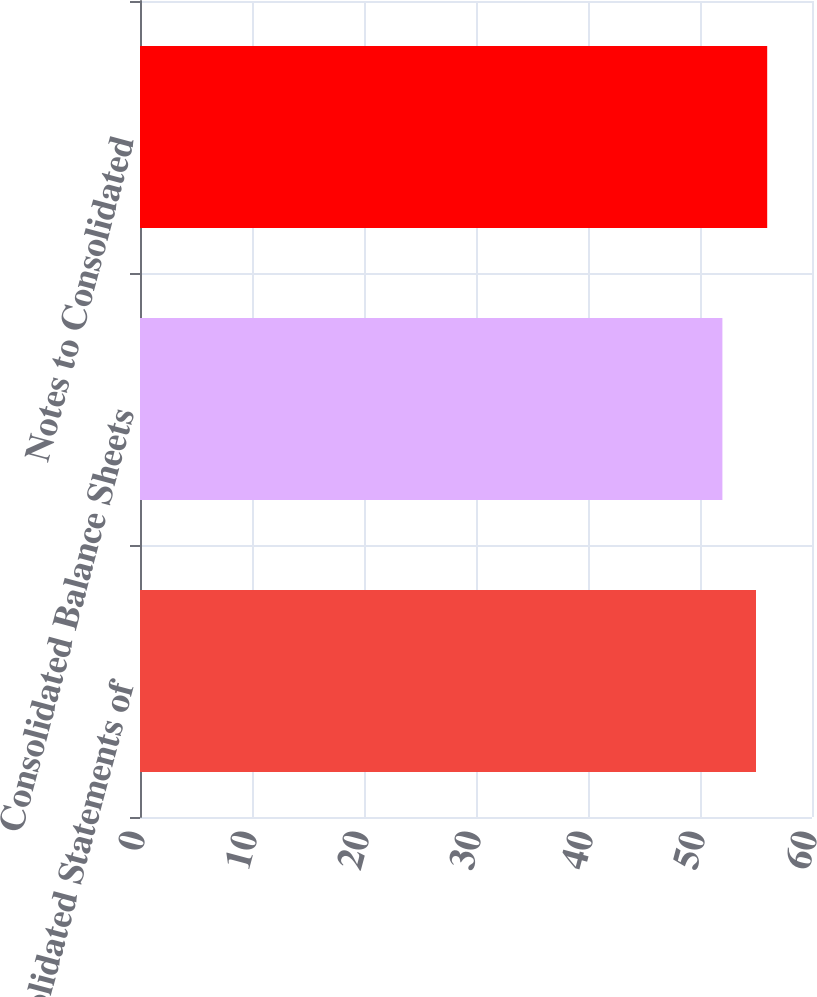Convert chart to OTSL. <chart><loc_0><loc_0><loc_500><loc_500><bar_chart><fcel>Consolidated Statements of<fcel>Consolidated Balance Sheets<fcel>Notes to Consolidated<nl><fcel>55<fcel>52<fcel>56<nl></chart> 